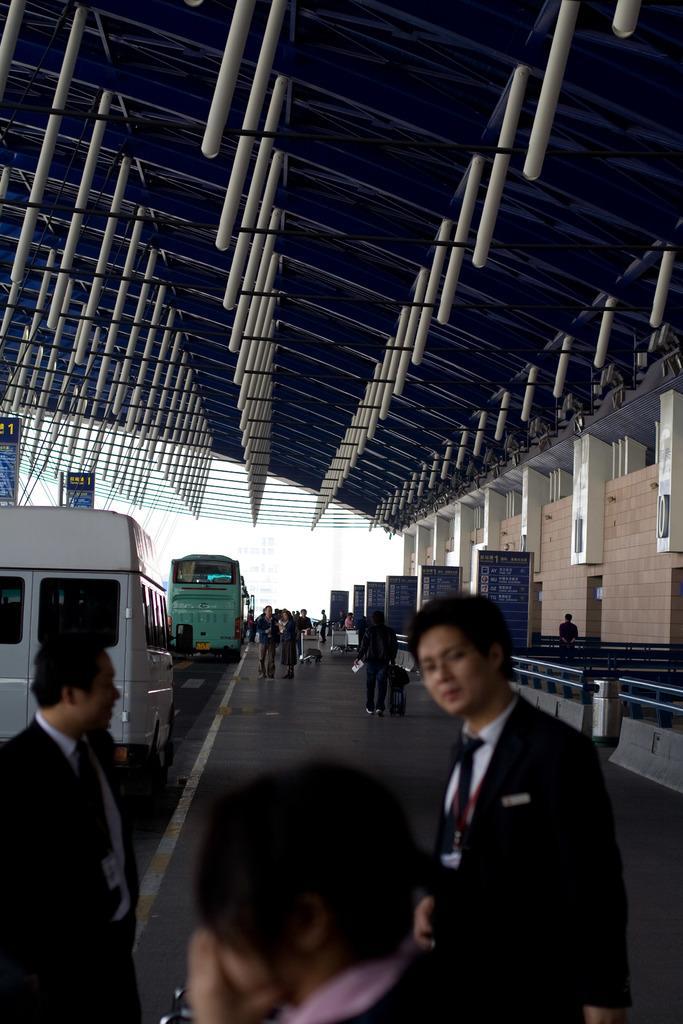Describe this image in one or two sentences. In this picture there are people in the center of the image and there are other people at the bottom side of the image, there are vehicles on the left side of the image and there is a boundary and posters on the right side of the image, there is a roof at the top side of the image. 